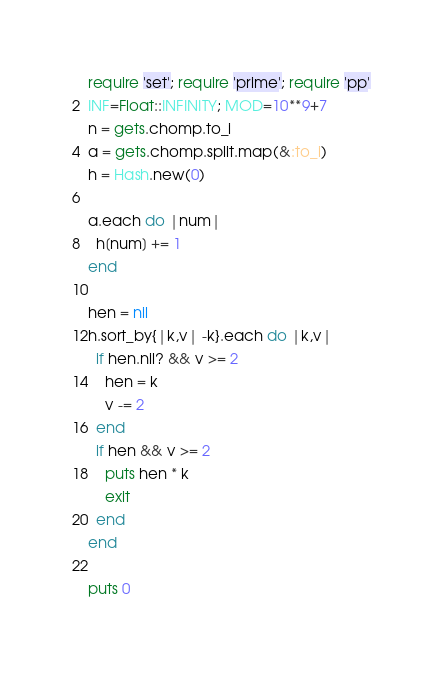Convert code to text. <code><loc_0><loc_0><loc_500><loc_500><_Ruby_>require 'set'; require 'prime'; require 'pp'
INF=Float::INFINITY; MOD=10**9+7
n = gets.chomp.to_i
a = gets.chomp.split.map(&:to_i)
h = Hash.new(0)

a.each do |num|
  h[num] += 1
end

hen = nil
h.sort_by{|k,v| -k}.each do |k,v|
  if hen.nil? && v >= 2
    hen = k
    v -= 2
  end
  if hen && v >= 2
    puts hen * k
    exit
  end
end

puts 0
</code> 